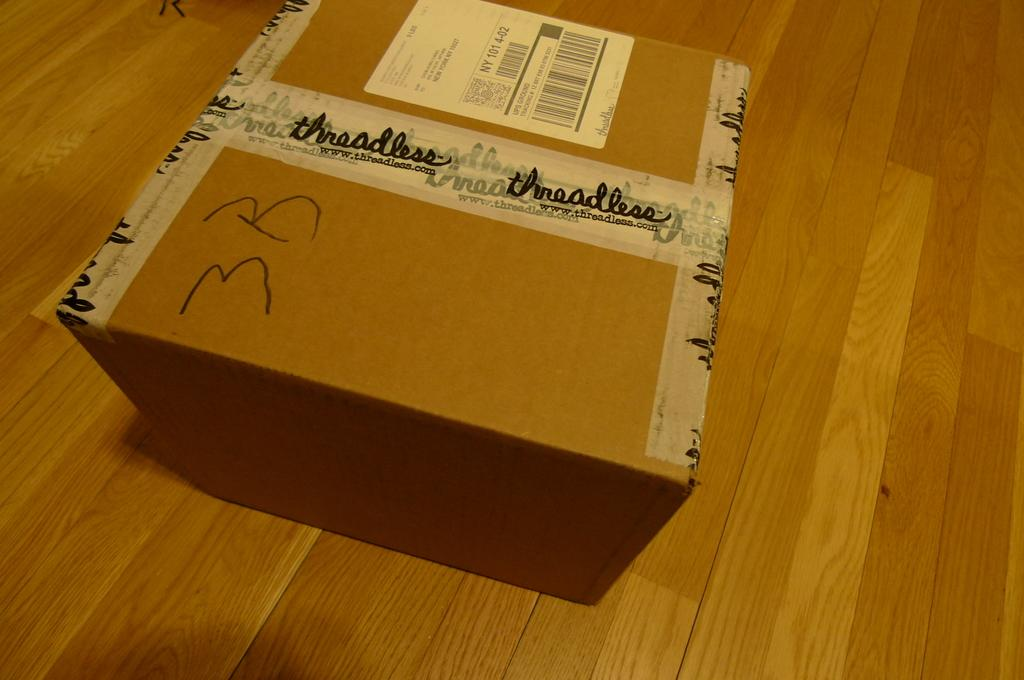<image>
Render a clear and concise summary of the photo. Large brown box from Threadless on the ground. 